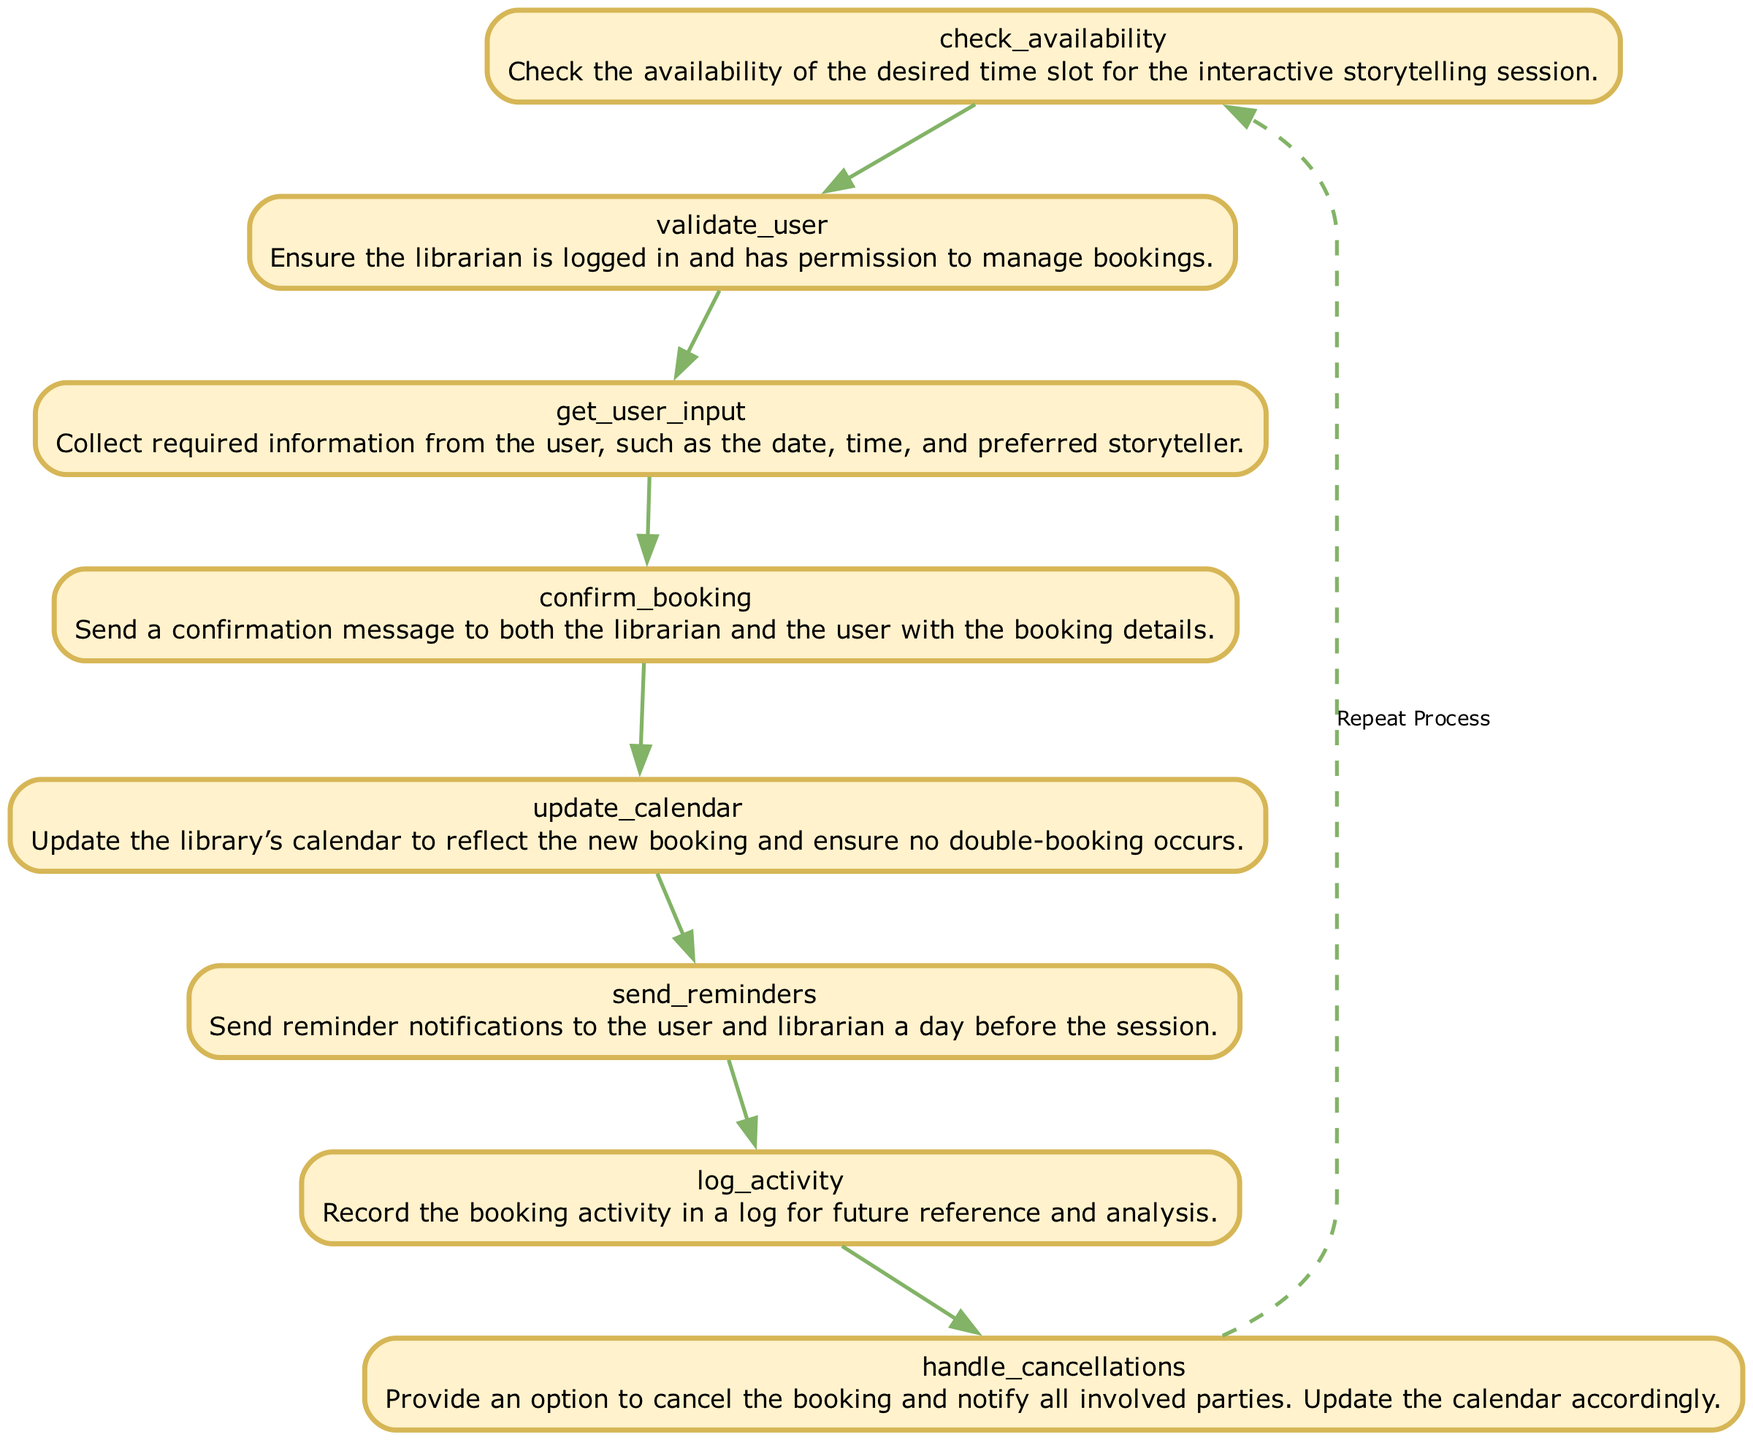what is the first step in managing a storytelling session booking? The first step is to check the availability of the desired time slot for the interactive storytelling session, as indicated at the beginning of the flowchart.
Answer: check availability how many elements are present in the diagram? The diagram contains eight elements related to managing interactive storytelling session bookings.
Answer: eight what action occurs after user input is collected? After gathering the required information from the user, the next action is to confirm the booking, which involves sending a confirmation message to both the librarian and the user.
Answer: confirm booking what do we do if a booking needs to be canceled? If a booking needs to be canceled, the flowchart indicates that we should handle cancellations, which involves providing an option to cancel the booking and notifying all involved parties.
Answer: handle cancellations which step involves updating the library’s calendar? The step that involves updating the library’s calendar is to update calendar, ensuring the new booking reflects and prevents any double bookings.
Answer: update calendar what action is taken to remind about the session? The action taken to remind about the session is sending reminders, which occurs a day before the session to both the user and the librarian.
Answer: send reminders which node follows the confirmation of the booking? Following the confirmation of the booking, the next step is to update the calendar to reflect the new booking and prevent double-booking occurrences.
Answer: update calendar what is the last action mentioned in the diagram before the process repeats? The last action mentioned before the process repeats is logging the activity, which involves recording the booking activity for future reference and analysis.
Answer: log activity 